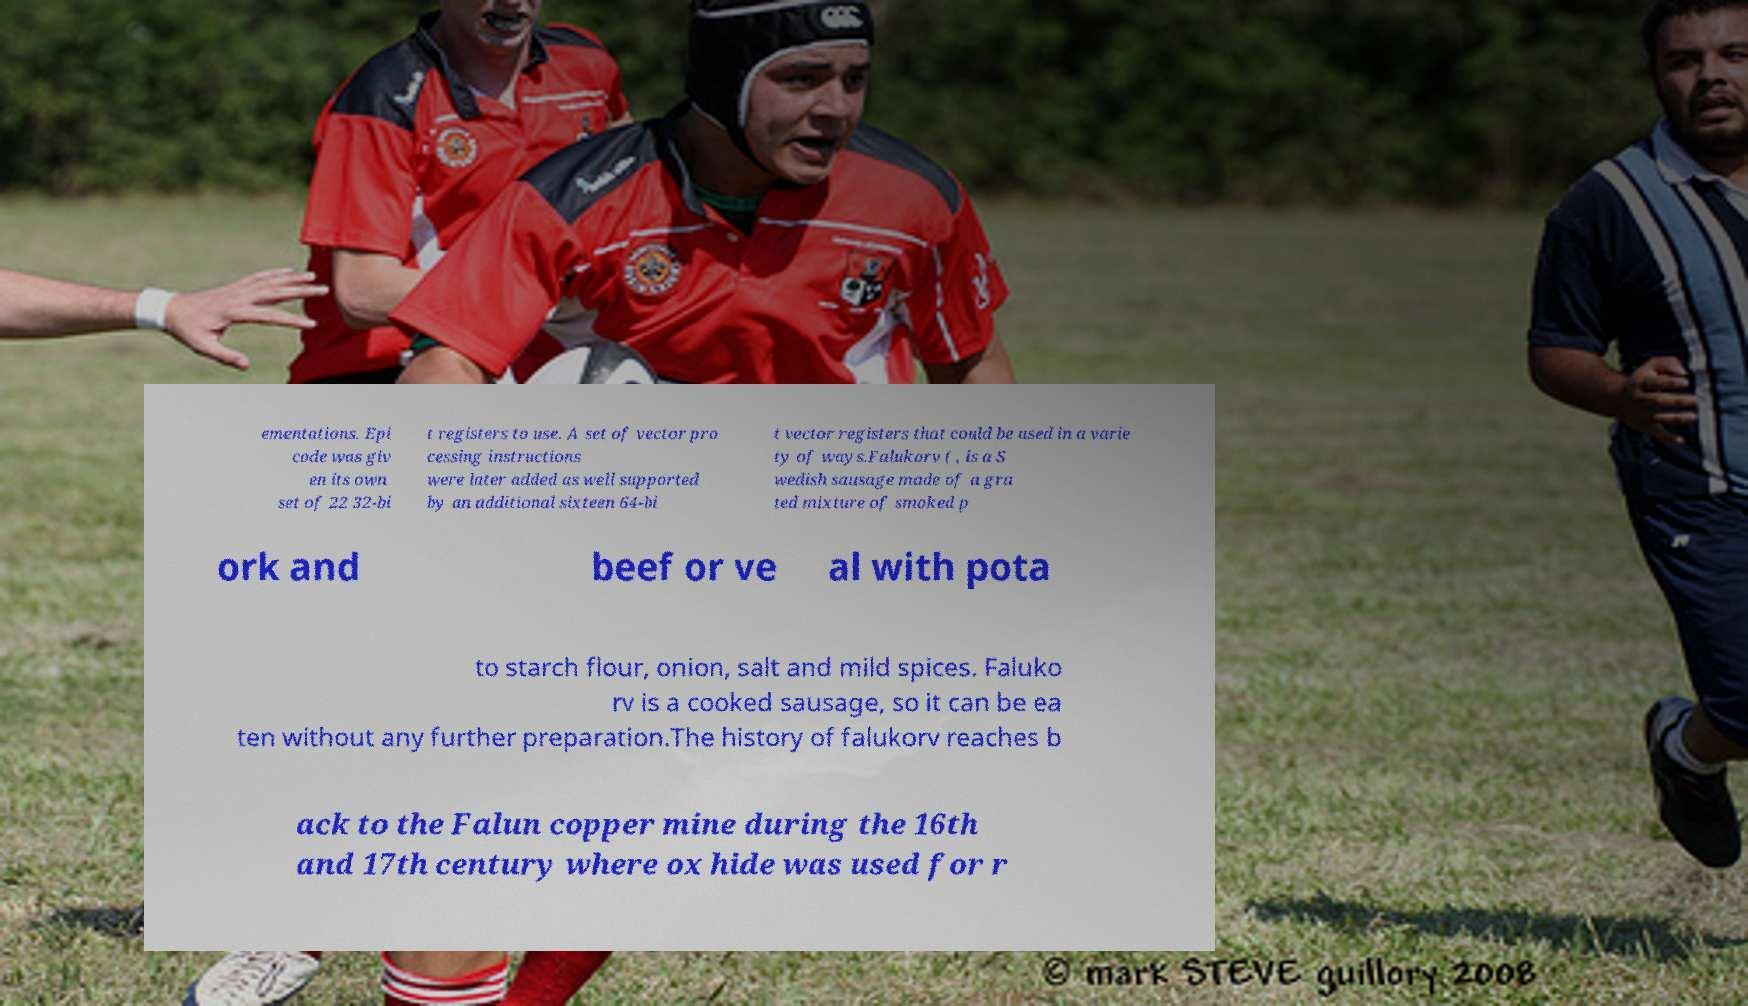Please identify and transcribe the text found in this image. ementations. Epi code was giv en its own set of 22 32-bi t registers to use. A set of vector pro cessing instructions were later added as well supported by an additional sixteen 64-bi t vector registers that could be used in a varie ty of ways.Falukorv ( , is a S wedish sausage made of a gra ted mixture of smoked p ork and beef or ve al with pota to starch flour, onion, salt and mild spices. Faluko rv is a cooked sausage, so it can be ea ten without any further preparation.The history of falukorv reaches b ack to the Falun copper mine during the 16th and 17th century where ox hide was used for r 